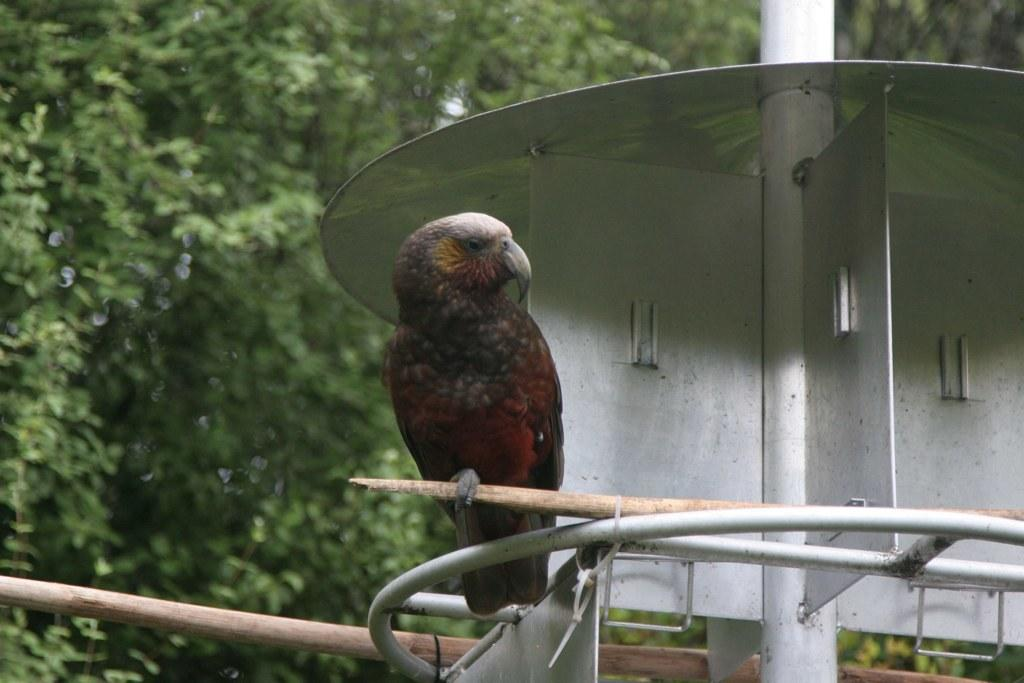What is the bird in the image holding? The bird is holding a stick in the image. What can be seen in the background of the image? There is a metal instrument and a pole in the background of the image, as well as trees. What advice does the bird give to the metal instrument in the image? There is no interaction between the bird and the metal instrument in the image, and therefore no advice can be given. 